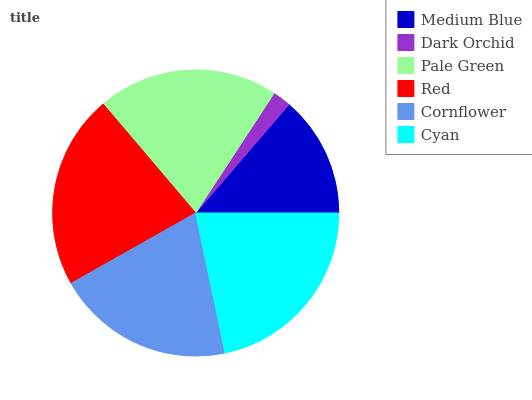Is Dark Orchid the minimum?
Answer yes or no. Yes. Is Red the maximum?
Answer yes or no. Yes. Is Pale Green the minimum?
Answer yes or no. No. Is Pale Green the maximum?
Answer yes or no. No. Is Pale Green greater than Dark Orchid?
Answer yes or no. Yes. Is Dark Orchid less than Pale Green?
Answer yes or no. Yes. Is Dark Orchid greater than Pale Green?
Answer yes or no. No. Is Pale Green less than Dark Orchid?
Answer yes or no. No. Is Pale Green the high median?
Answer yes or no. Yes. Is Cornflower the low median?
Answer yes or no. Yes. Is Cornflower the high median?
Answer yes or no. No. Is Pale Green the low median?
Answer yes or no. No. 